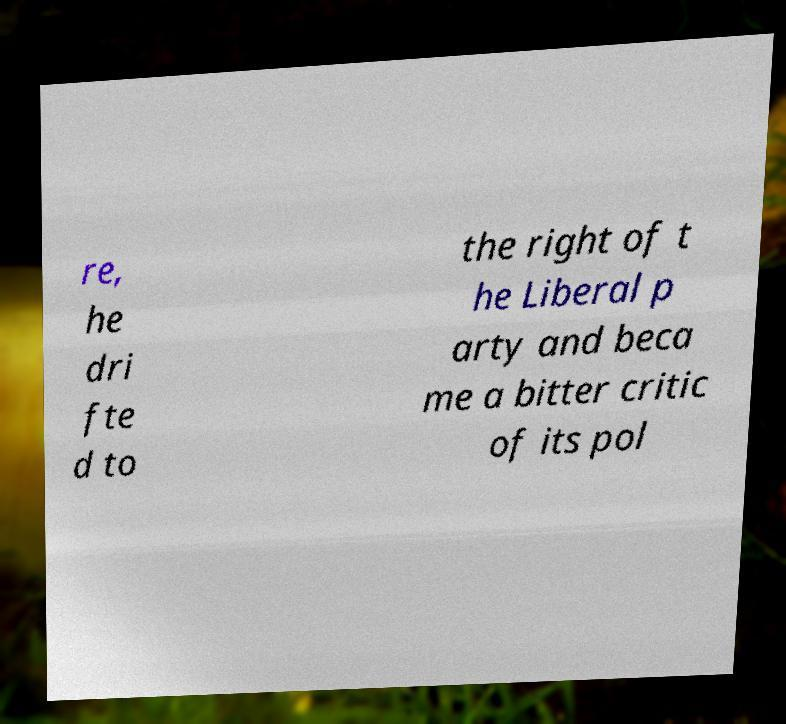There's text embedded in this image that I need extracted. Can you transcribe it verbatim? re, he dri fte d to the right of t he Liberal p arty and beca me a bitter critic of its pol 